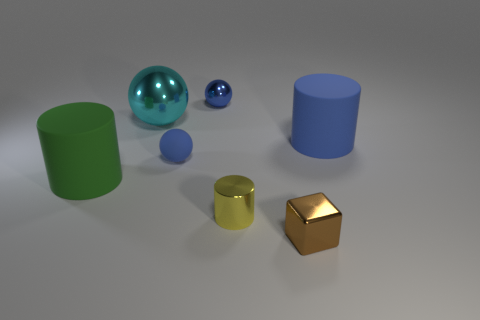What shape is the cyan object that is made of the same material as the tiny brown cube?
Ensure brevity in your answer.  Sphere. What number of small yellow shiny things are the same shape as the big green thing?
Your response must be concise. 1. There is a blue rubber ball in front of the tiny shiny object behind the blue cylinder; what size is it?
Offer a terse response. Small. Does the big matte object that is behind the big green matte object have the same color as the rubber object that is left of the small rubber ball?
Ensure brevity in your answer.  No. There is a yellow cylinder in front of the big rubber thing that is behind the blue rubber ball; what number of cyan metallic balls are behind it?
Your answer should be compact. 1. How many shiny things are in front of the big cyan metal object and behind the tiny brown cube?
Your answer should be compact. 1. Is the number of cubes on the left side of the yellow metal cylinder greater than the number of small cyan metallic blocks?
Offer a very short reply. No. What number of cyan metal things are the same size as the blue cylinder?
Keep it short and to the point. 1. What is the size of the rubber cylinder that is the same color as the small metal ball?
Your answer should be very brief. Large. How many tiny things are either red objects or cyan metal balls?
Offer a very short reply. 0. 